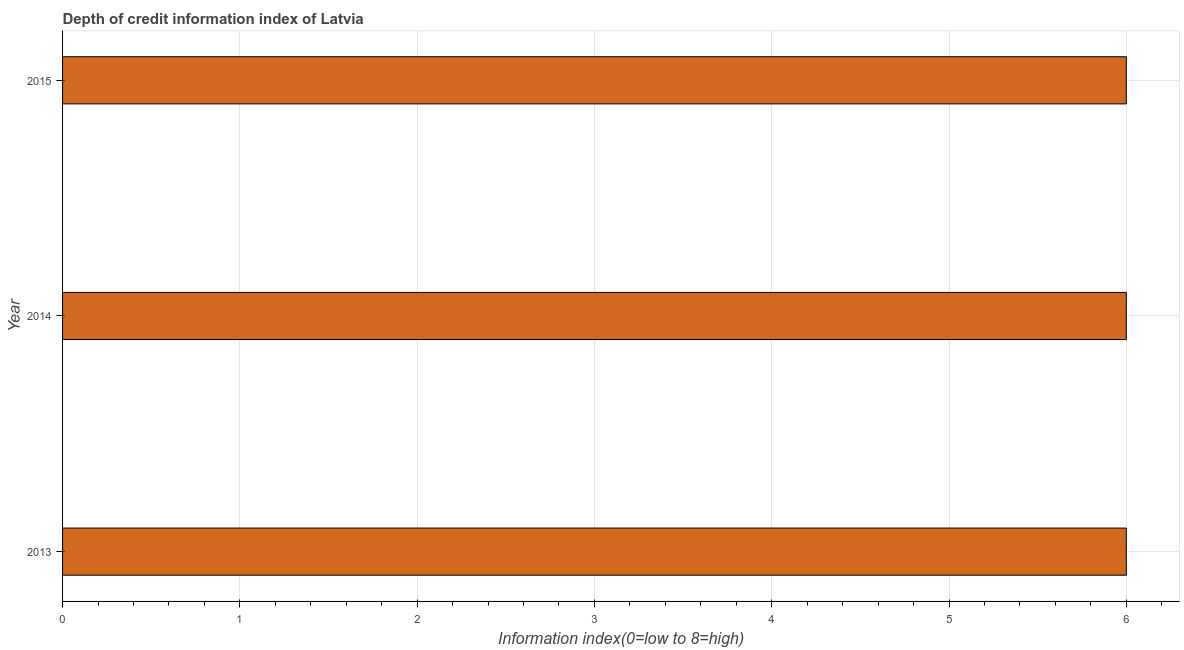Does the graph contain any zero values?
Make the answer very short. No. What is the title of the graph?
Your answer should be compact. Depth of credit information index of Latvia. What is the label or title of the X-axis?
Provide a succinct answer. Information index(0=low to 8=high). What is the depth of credit information index in 2014?
Offer a terse response. 6. Across all years, what is the maximum depth of credit information index?
Ensure brevity in your answer.  6. In which year was the depth of credit information index maximum?
Your answer should be very brief. 2013. What is the sum of the depth of credit information index?
Ensure brevity in your answer.  18. What is the average depth of credit information index per year?
Provide a short and direct response. 6. What is the median depth of credit information index?
Offer a very short reply. 6. In how many years, is the depth of credit information index greater than 4.4 ?
Offer a very short reply. 3. Do a majority of the years between 2014 and 2013 (inclusive) have depth of credit information index greater than 2.8 ?
Keep it short and to the point. No. In how many years, is the depth of credit information index greater than the average depth of credit information index taken over all years?
Your answer should be compact. 0. How many bars are there?
Ensure brevity in your answer.  3. What is the difference between two consecutive major ticks on the X-axis?
Give a very brief answer. 1. What is the Information index(0=low to 8=high) of 2014?
Your response must be concise. 6. What is the difference between the Information index(0=low to 8=high) in 2014 and 2015?
Give a very brief answer. 0. What is the ratio of the Information index(0=low to 8=high) in 2013 to that in 2014?
Your answer should be very brief. 1. What is the ratio of the Information index(0=low to 8=high) in 2013 to that in 2015?
Ensure brevity in your answer.  1. What is the ratio of the Information index(0=low to 8=high) in 2014 to that in 2015?
Provide a short and direct response. 1. 